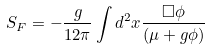Convert formula to latex. <formula><loc_0><loc_0><loc_500><loc_500>S _ { F } = - \frac { g } { 1 2 \pi } \int d ^ { 2 } x \frac { \Box \phi } { ( \mu + g \phi ) }</formula> 